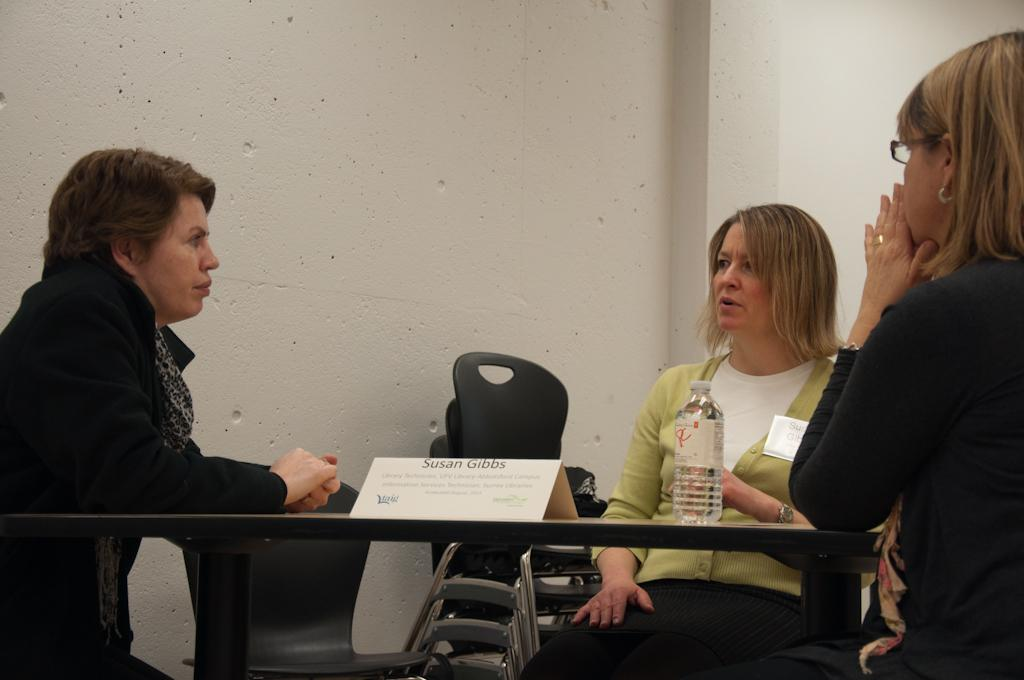How many people are sitting in the image? There are three persons sitting on chairs in the image. What is on the table in the image? There is a bottle and a name board on the table in the image. Are there any chairs on the table? Yes, there are chairs on the table in the image. What can be seen in the background of the image? There is a wall in the background of the image. What type of carpenter is visible in the image? There is no carpenter present in the image. What is the view from the chairs in the image? The provided facts do not give information about the view from the chairs, so it cannot be determined from the image. 